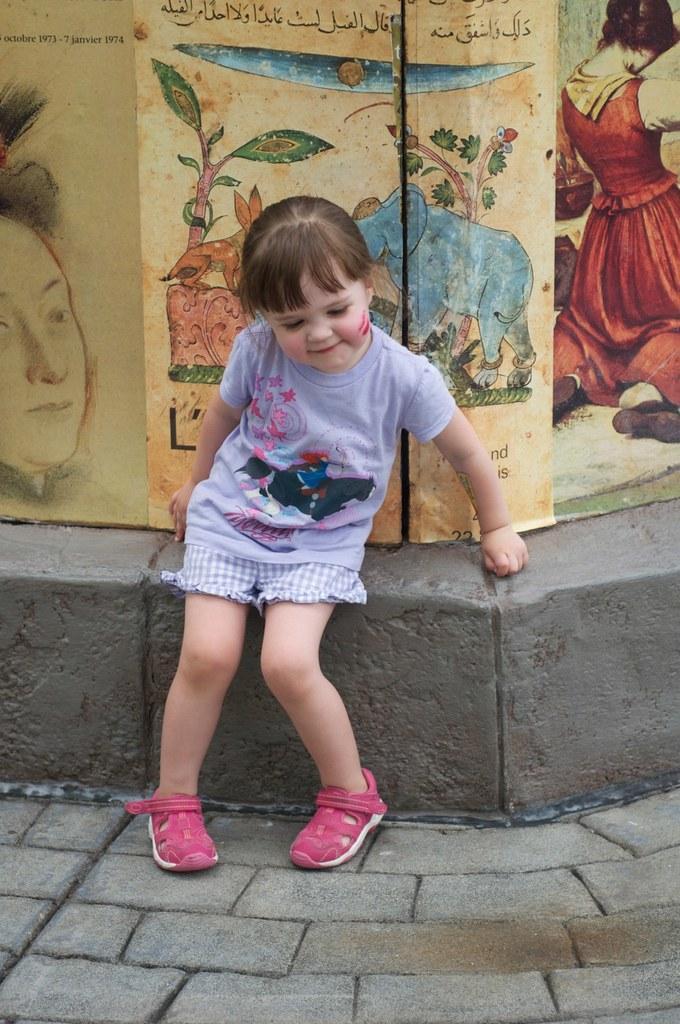Could you give a brief overview of what you see in this image? This image consists of a girl wearing a T-shirt and pink shoes. At the bottom, there is a pavement. In the background, there is a wall on which there are posters. 